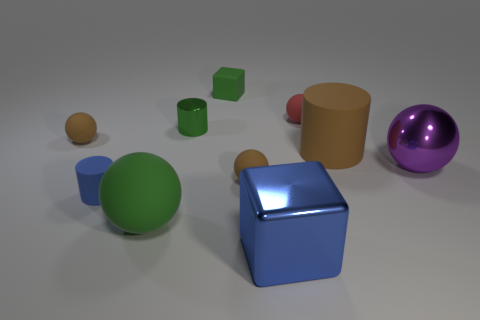Subtract all purple metallic spheres. How many spheres are left? 4 Subtract all red balls. How many balls are left? 4 Subtract all yellow spheres. Subtract all red blocks. How many spheres are left? 5 Subtract all cylinders. How many objects are left? 7 Add 8 cyan rubber cylinders. How many cyan rubber cylinders exist? 8 Subtract 1 green cylinders. How many objects are left? 9 Subtract all large brown cylinders. Subtract all red things. How many objects are left? 8 Add 5 large blue metal cubes. How many large blue metal cubes are left? 6 